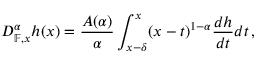<formula> <loc_0><loc_0><loc_500><loc_500>D _ { \mathbb { F } , x } ^ { \alpha } h ( x ) = \frac { A ( \alpha ) } { \alpha } \int _ { x - \delta } ^ { x } ( x - t ) ^ { 1 - \alpha } \frac { d h } { d t } d t \, ,</formula> 